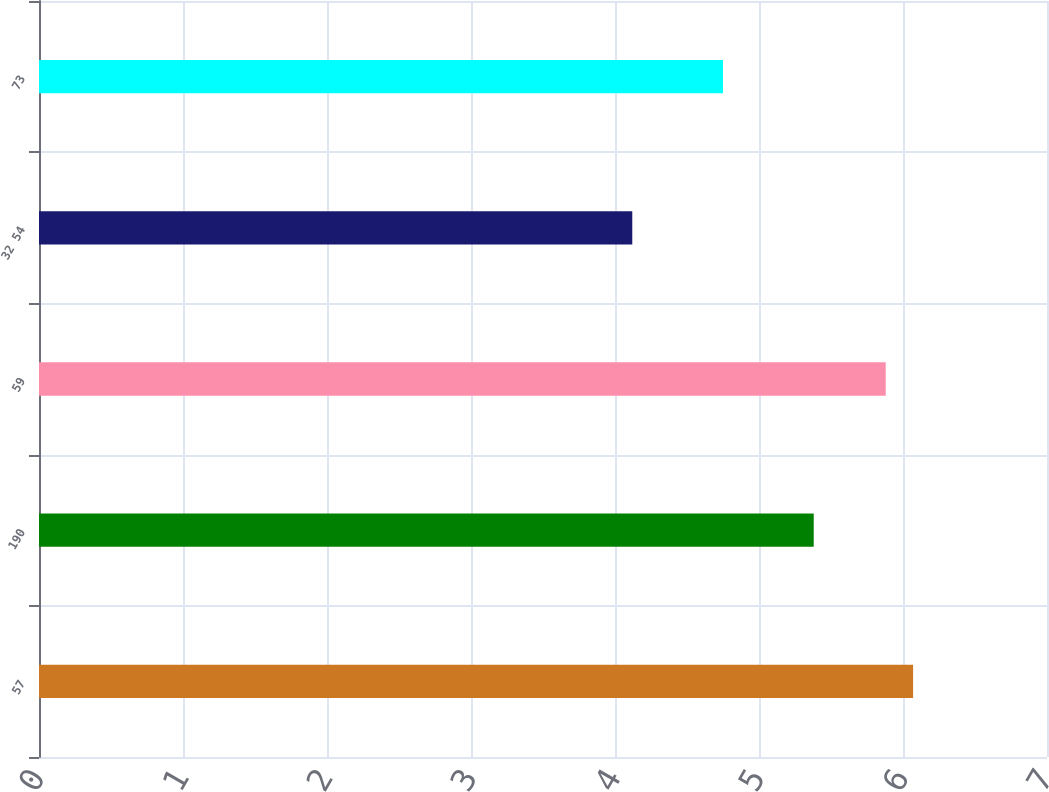<chart> <loc_0><loc_0><loc_500><loc_500><bar_chart><fcel>57<fcel>190<fcel>59<fcel>32 54<fcel>73<nl><fcel>6.07<fcel>5.38<fcel>5.88<fcel>4.12<fcel>4.75<nl></chart> 